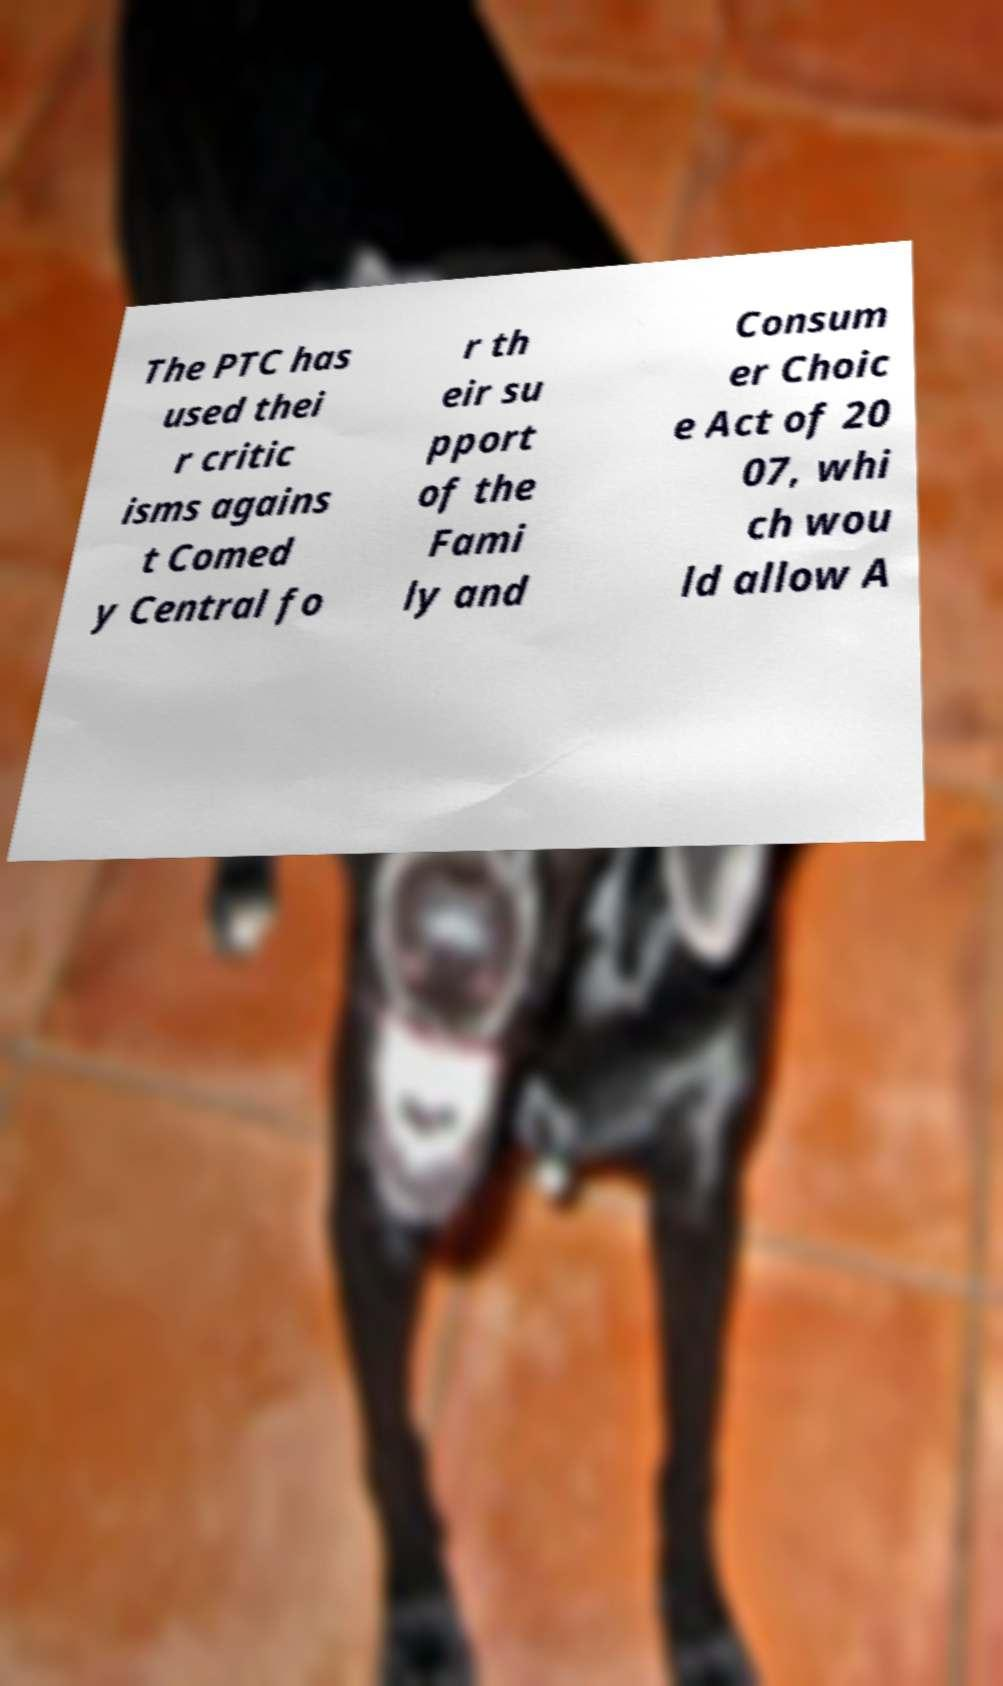Can you read and provide the text displayed in the image?This photo seems to have some interesting text. Can you extract and type it out for me? The PTC has used thei r critic isms agains t Comed y Central fo r th eir su pport of the Fami ly and Consum er Choic e Act of 20 07, whi ch wou ld allow A 